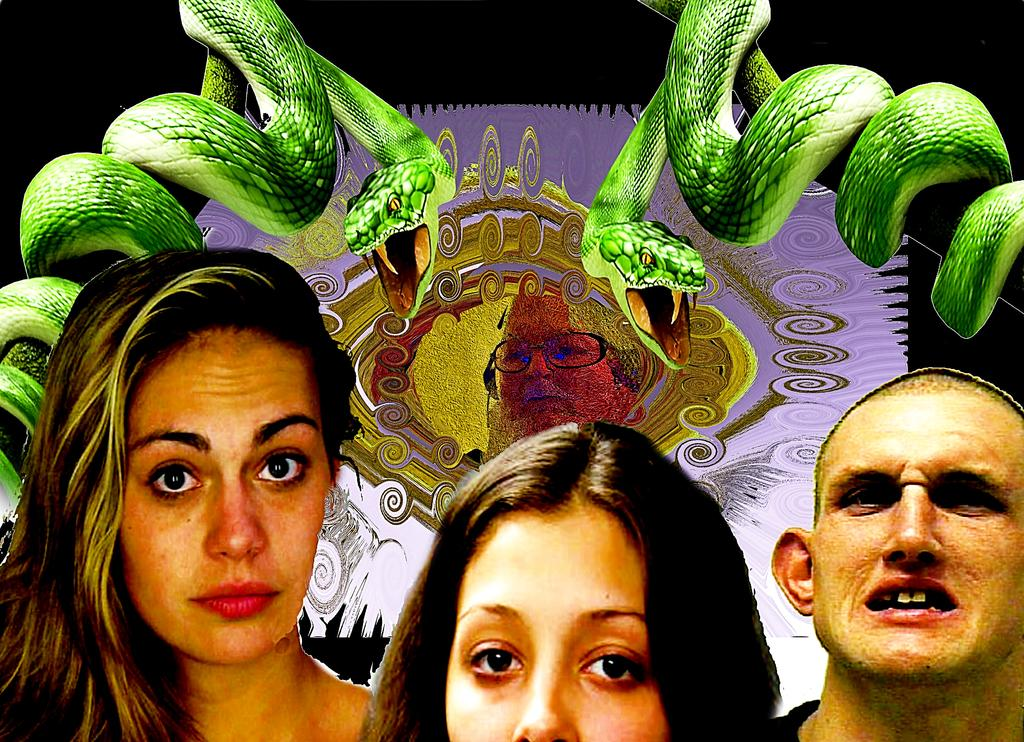How many people are in the image? There are three persons in the image. What else can be seen in the image besides the people? There are snakes in the image. Is there any text or image on a banner in the image? Yes, there is a banner with a picture of a person in the image. What is the color of the background in the image? The background of the image is dark. Where is the hospital located in the image? There is no hospital present in the image. What type of giants can be seen interacting with the snakes in the image? There are no giants present in the image; it features three persons and snakes. 